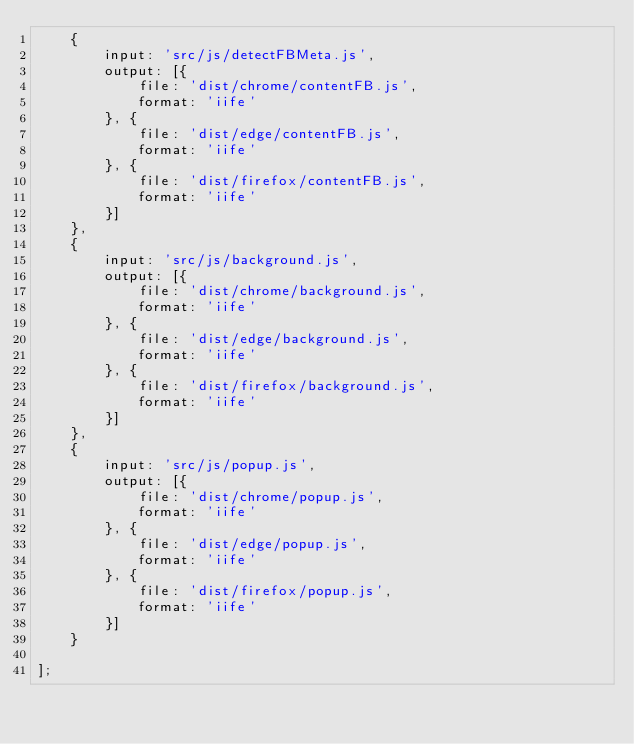Convert code to text. <code><loc_0><loc_0><loc_500><loc_500><_JavaScript_>    {
        input: 'src/js/detectFBMeta.js',
        output: [{
            file: 'dist/chrome/contentFB.js',
            format: 'iife'
        }, {
            file: 'dist/edge/contentFB.js',
            format: 'iife'
        }, {
            file: 'dist/firefox/contentFB.js',
            format: 'iife'
        }]
    },
    {
        input: 'src/js/background.js',
        output: [{
            file: 'dist/chrome/background.js',
            format: 'iife'
        }, {
            file: 'dist/edge/background.js',
            format: 'iife'
        }, {
            file: 'dist/firefox/background.js',
            format: 'iife'
        }]
    },
    {
        input: 'src/js/popup.js',
        output: [{
            file: 'dist/chrome/popup.js',
            format: 'iife'
        }, {
            file: 'dist/edge/popup.js',
            format: 'iife'
        }, {
            file: 'dist/firefox/popup.js',
            format: 'iife'
        }]
    }

];
</code> 